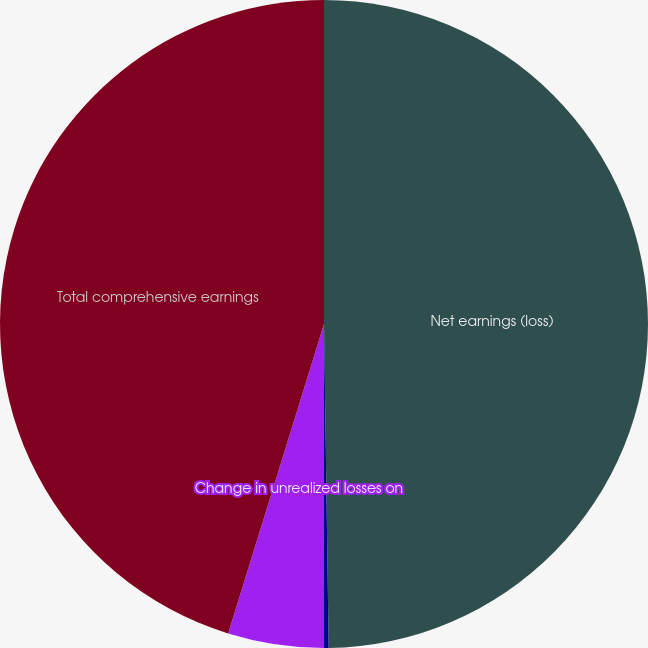<chart> <loc_0><loc_0><loc_500><loc_500><pie_chart><fcel>Net earnings (loss)<fcel>Reclassification adjustment<fcel>Change in unrealized losses on<fcel>Total comprehensive earnings<nl><fcel>49.77%<fcel>0.23%<fcel>4.78%<fcel>45.22%<nl></chart> 